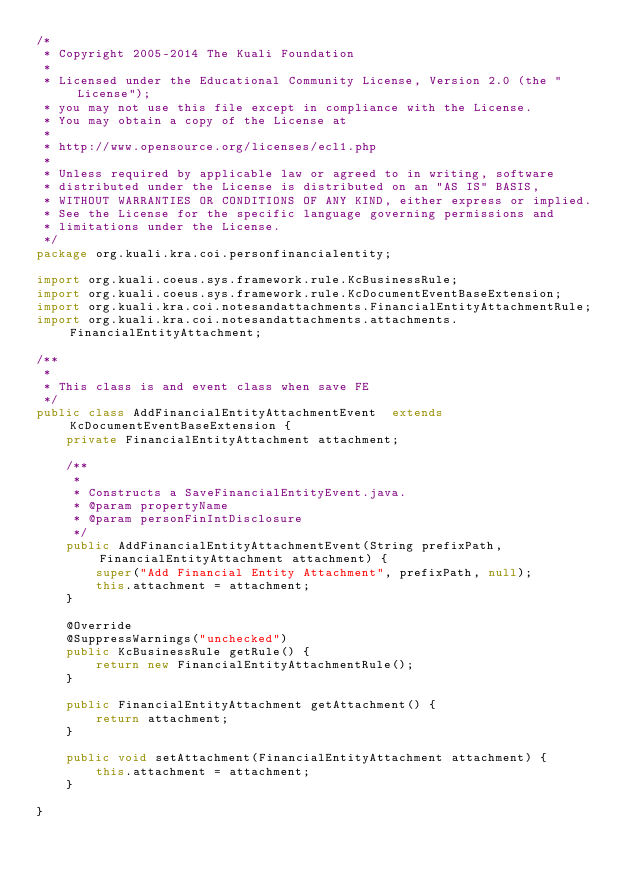Convert code to text. <code><loc_0><loc_0><loc_500><loc_500><_Java_>/*
 * Copyright 2005-2014 The Kuali Foundation
 * 
 * Licensed under the Educational Community License, Version 2.0 (the "License");
 * you may not use this file except in compliance with the License.
 * You may obtain a copy of the License at
 * 
 * http://www.opensource.org/licenses/ecl1.php
 * 
 * Unless required by applicable law or agreed to in writing, software
 * distributed under the License is distributed on an "AS IS" BASIS,
 * WITHOUT WARRANTIES OR CONDITIONS OF ANY KIND, either express or implied.
 * See the License for the specific language governing permissions and
 * limitations under the License.
 */
package org.kuali.kra.coi.personfinancialentity;

import org.kuali.coeus.sys.framework.rule.KcBusinessRule;
import org.kuali.coeus.sys.framework.rule.KcDocumentEventBaseExtension;
import org.kuali.kra.coi.notesandattachments.FinancialEntityAttachmentRule;
import org.kuali.kra.coi.notesandattachments.attachments.FinancialEntityAttachment;

/**
 * 
 * This class is and event class when save FE
 */
public class AddFinancialEntityAttachmentEvent  extends KcDocumentEventBaseExtension {
    private FinancialEntityAttachment attachment;

    /**
     * 
     * Constructs a SaveFinancialEntityEvent.java.
     * @param propertyName
     * @param personFinIntDisclosure
     */
    public AddFinancialEntityAttachmentEvent(String prefixPath, FinancialEntityAttachment attachment) {
        super("Add Financial Entity Attachment", prefixPath, null);
        this.attachment = attachment;
    }
    
    @Override
    @SuppressWarnings("unchecked")
    public KcBusinessRule getRule() {
        return new FinancialEntityAttachmentRule();
    }

    public FinancialEntityAttachment getAttachment() {
        return attachment;
    }

    public void setAttachment(FinancialEntityAttachment attachment) {
        this.attachment = attachment;
    }

}
</code> 